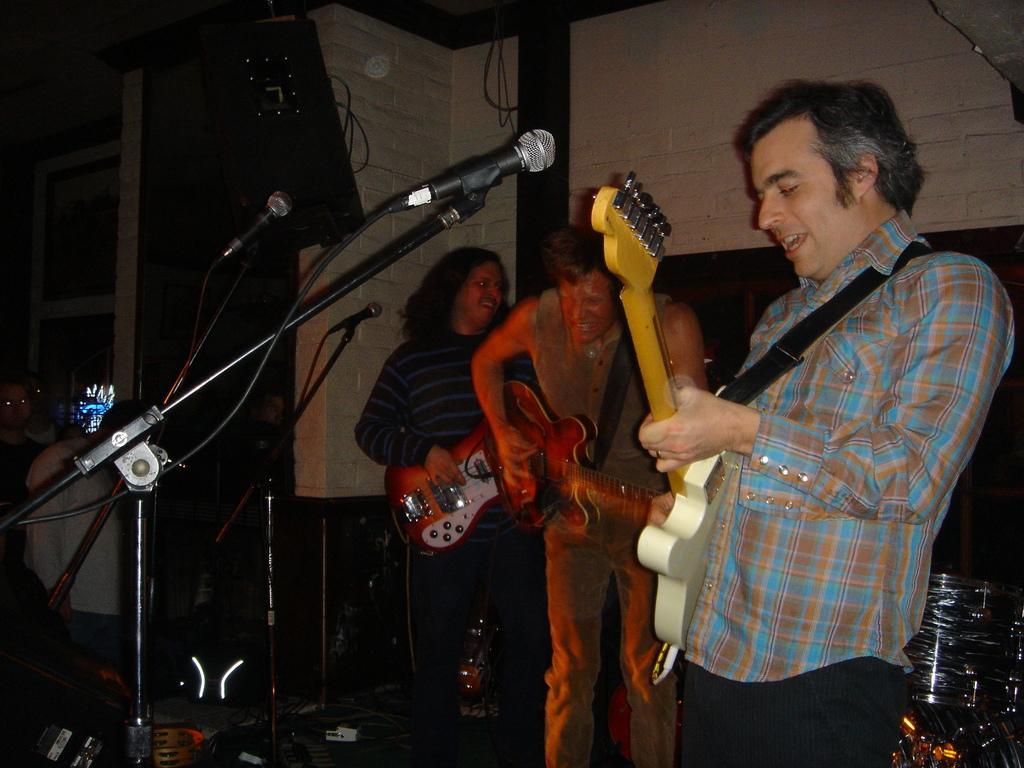Please provide a concise description of this image. It is a music concert the musicians are playing the music there are total three people they are holding the guitars,behind them there are few other people standing, in the background there is a brick wall and also speakers and some drums. 